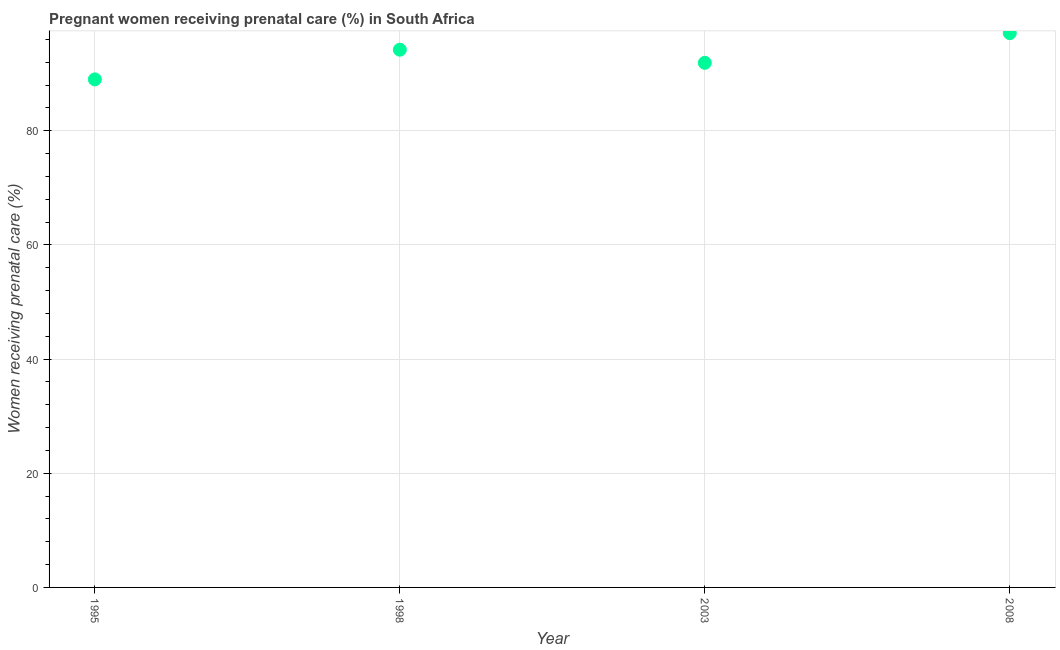What is the percentage of pregnant women receiving prenatal care in 2003?
Your response must be concise. 91.9. Across all years, what is the maximum percentage of pregnant women receiving prenatal care?
Provide a short and direct response. 97.1. Across all years, what is the minimum percentage of pregnant women receiving prenatal care?
Offer a terse response. 89. In which year was the percentage of pregnant women receiving prenatal care minimum?
Ensure brevity in your answer.  1995. What is the sum of the percentage of pregnant women receiving prenatal care?
Give a very brief answer. 372.2. What is the difference between the percentage of pregnant women receiving prenatal care in 1995 and 2008?
Your response must be concise. -8.1. What is the average percentage of pregnant women receiving prenatal care per year?
Offer a very short reply. 93.05. What is the median percentage of pregnant women receiving prenatal care?
Provide a short and direct response. 93.05. In how many years, is the percentage of pregnant women receiving prenatal care greater than 40 %?
Offer a very short reply. 4. Do a majority of the years between 2003 and 1998 (inclusive) have percentage of pregnant women receiving prenatal care greater than 8 %?
Your answer should be very brief. No. What is the ratio of the percentage of pregnant women receiving prenatal care in 1998 to that in 2008?
Your response must be concise. 0.97. Is the difference between the percentage of pregnant women receiving prenatal care in 1998 and 2008 greater than the difference between any two years?
Make the answer very short. No. What is the difference between the highest and the second highest percentage of pregnant women receiving prenatal care?
Make the answer very short. 2.9. Is the sum of the percentage of pregnant women receiving prenatal care in 1998 and 2008 greater than the maximum percentage of pregnant women receiving prenatal care across all years?
Keep it short and to the point. Yes. What is the difference between the highest and the lowest percentage of pregnant women receiving prenatal care?
Offer a very short reply. 8.1. In how many years, is the percentage of pregnant women receiving prenatal care greater than the average percentage of pregnant women receiving prenatal care taken over all years?
Keep it short and to the point. 2. Are the values on the major ticks of Y-axis written in scientific E-notation?
Offer a terse response. No. Does the graph contain any zero values?
Your answer should be very brief. No. Does the graph contain grids?
Keep it short and to the point. Yes. What is the title of the graph?
Your answer should be very brief. Pregnant women receiving prenatal care (%) in South Africa. What is the label or title of the X-axis?
Your response must be concise. Year. What is the label or title of the Y-axis?
Ensure brevity in your answer.  Women receiving prenatal care (%). What is the Women receiving prenatal care (%) in 1995?
Offer a very short reply. 89. What is the Women receiving prenatal care (%) in 1998?
Provide a succinct answer. 94.2. What is the Women receiving prenatal care (%) in 2003?
Your response must be concise. 91.9. What is the Women receiving prenatal care (%) in 2008?
Provide a succinct answer. 97.1. What is the difference between the Women receiving prenatal care (%) in 1995 and 1998?
Make the answer very short. -5.2. What is the difference between the Women receiving prenatal care (%) in 1998 and 2008?
Ensure brevity in your answer.  -2.9. What is the difference between the Women receiving prenatal care (%) in 2003 and 2008?
Offer a terse response. -5.2. What is the ratio of the Women receiving prenatal care (%) in 1995 to that in 1998?
Your response must be concise. 0.94. What is the ratio of the Women receiving prenatal care (%) in 1995 to that in 2008?
Provide a succinct answer. 0.92. What is the ratio of the Women receiving prenatal care (%) in 2003 to that in 2008?
Make the answer very short. 0.95. 